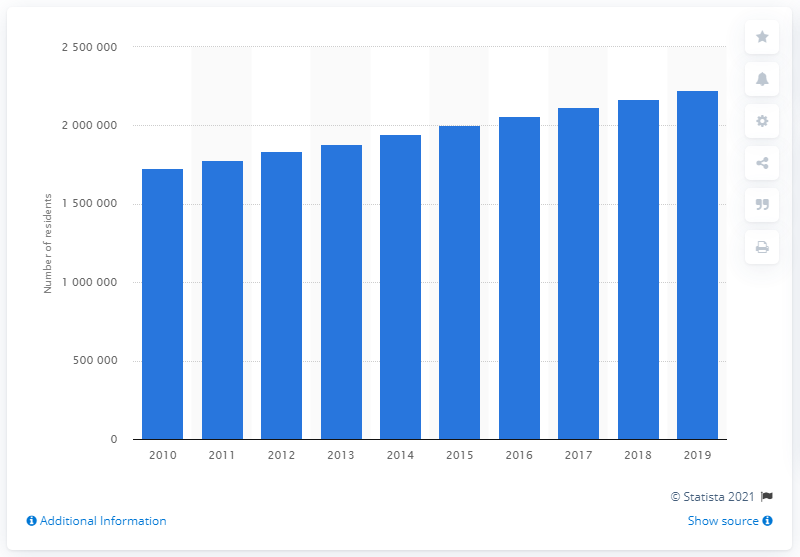Identify some key points in this picture. In the year 2019, there were approximately 2,227,083 people living in the Austin-Round Rock metropolitan area. 